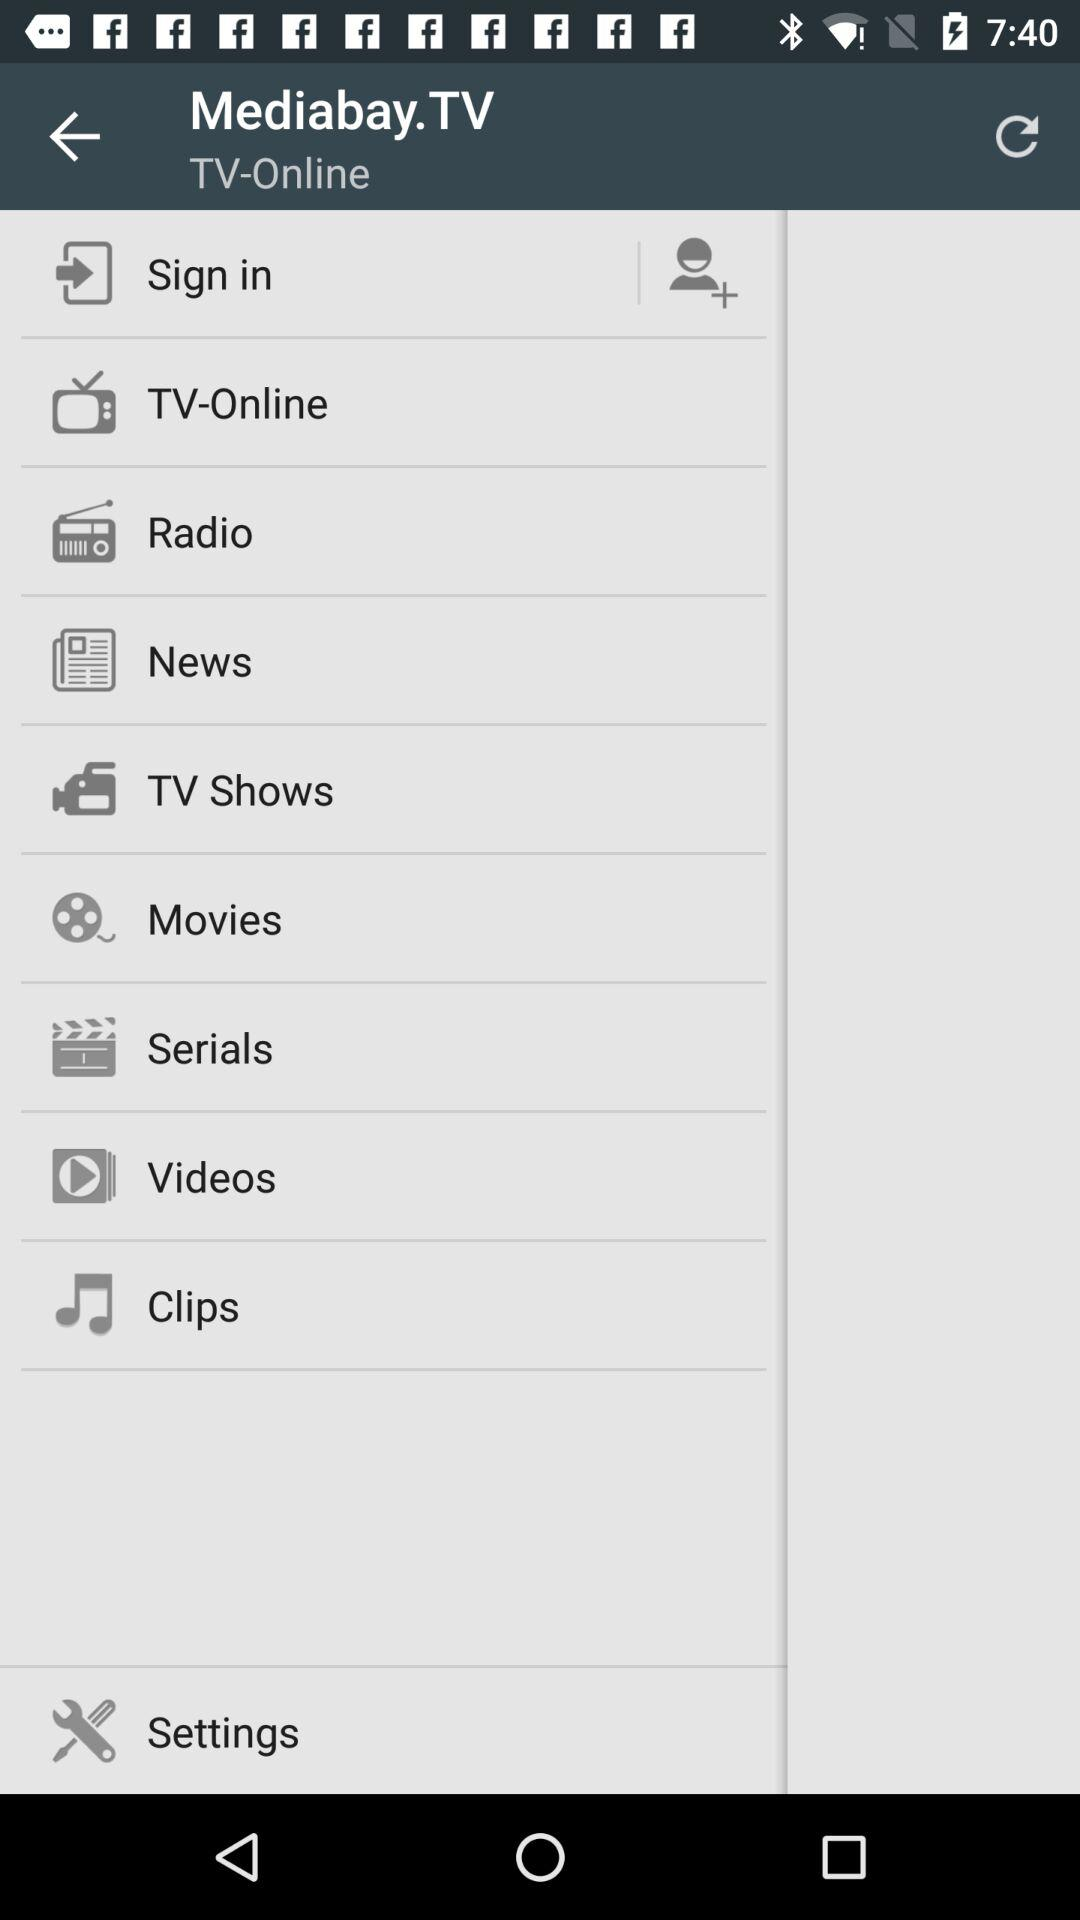How many notifications are there in "News"?
When the provided information is insufficient, respond with <no answer>. <no answer> 